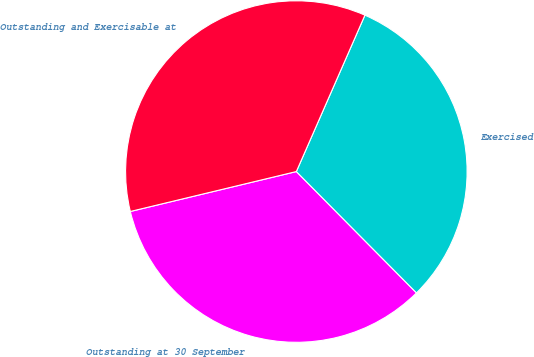Convert chart to OTSL. <chart><loc_0><loc_0><loc_500><loc_500><pie_chart><fcel>Outstanding at 30 September<fcel>Exercised<fcel>Outstanding and Exercisable at<nl><fcel>33.66%<fcel>31.0%<fcel>35.33%<nl></chart> 